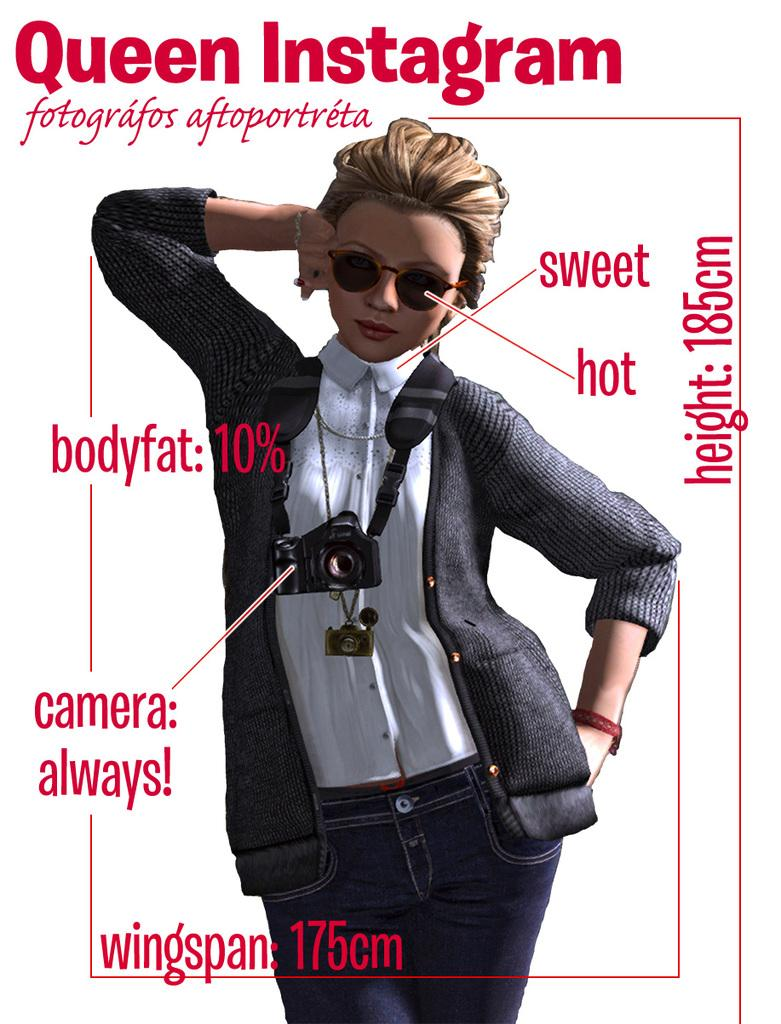What is present in the image that features an image and text? There is a poster in the image that contains an image and text. What type of image is on the poster? The image on the poster is of a woman. Where is the car parked in relation to the poster in the image? There is no car present in the image; it only features a poster with an image of a woman and text. 